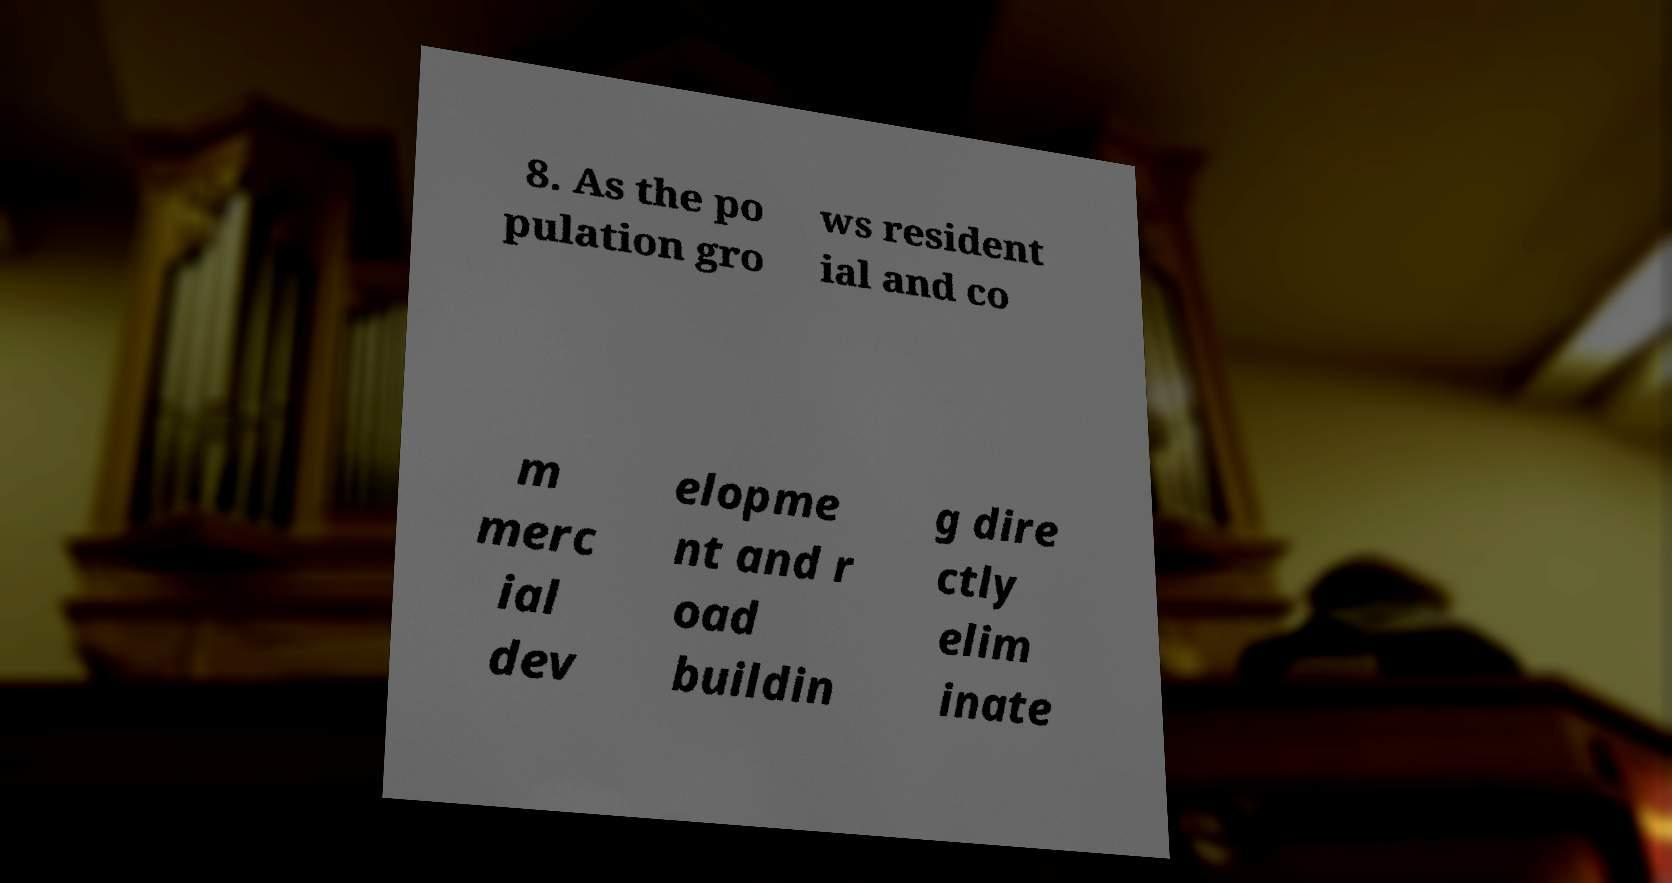There's text embedded in this image that I need extracted. Can you transcribe it verbatim? 8. As the po pulation gro ws resident ial and co m merc ial dev elopme nt and r oad buildin g dire ctly elim inate 